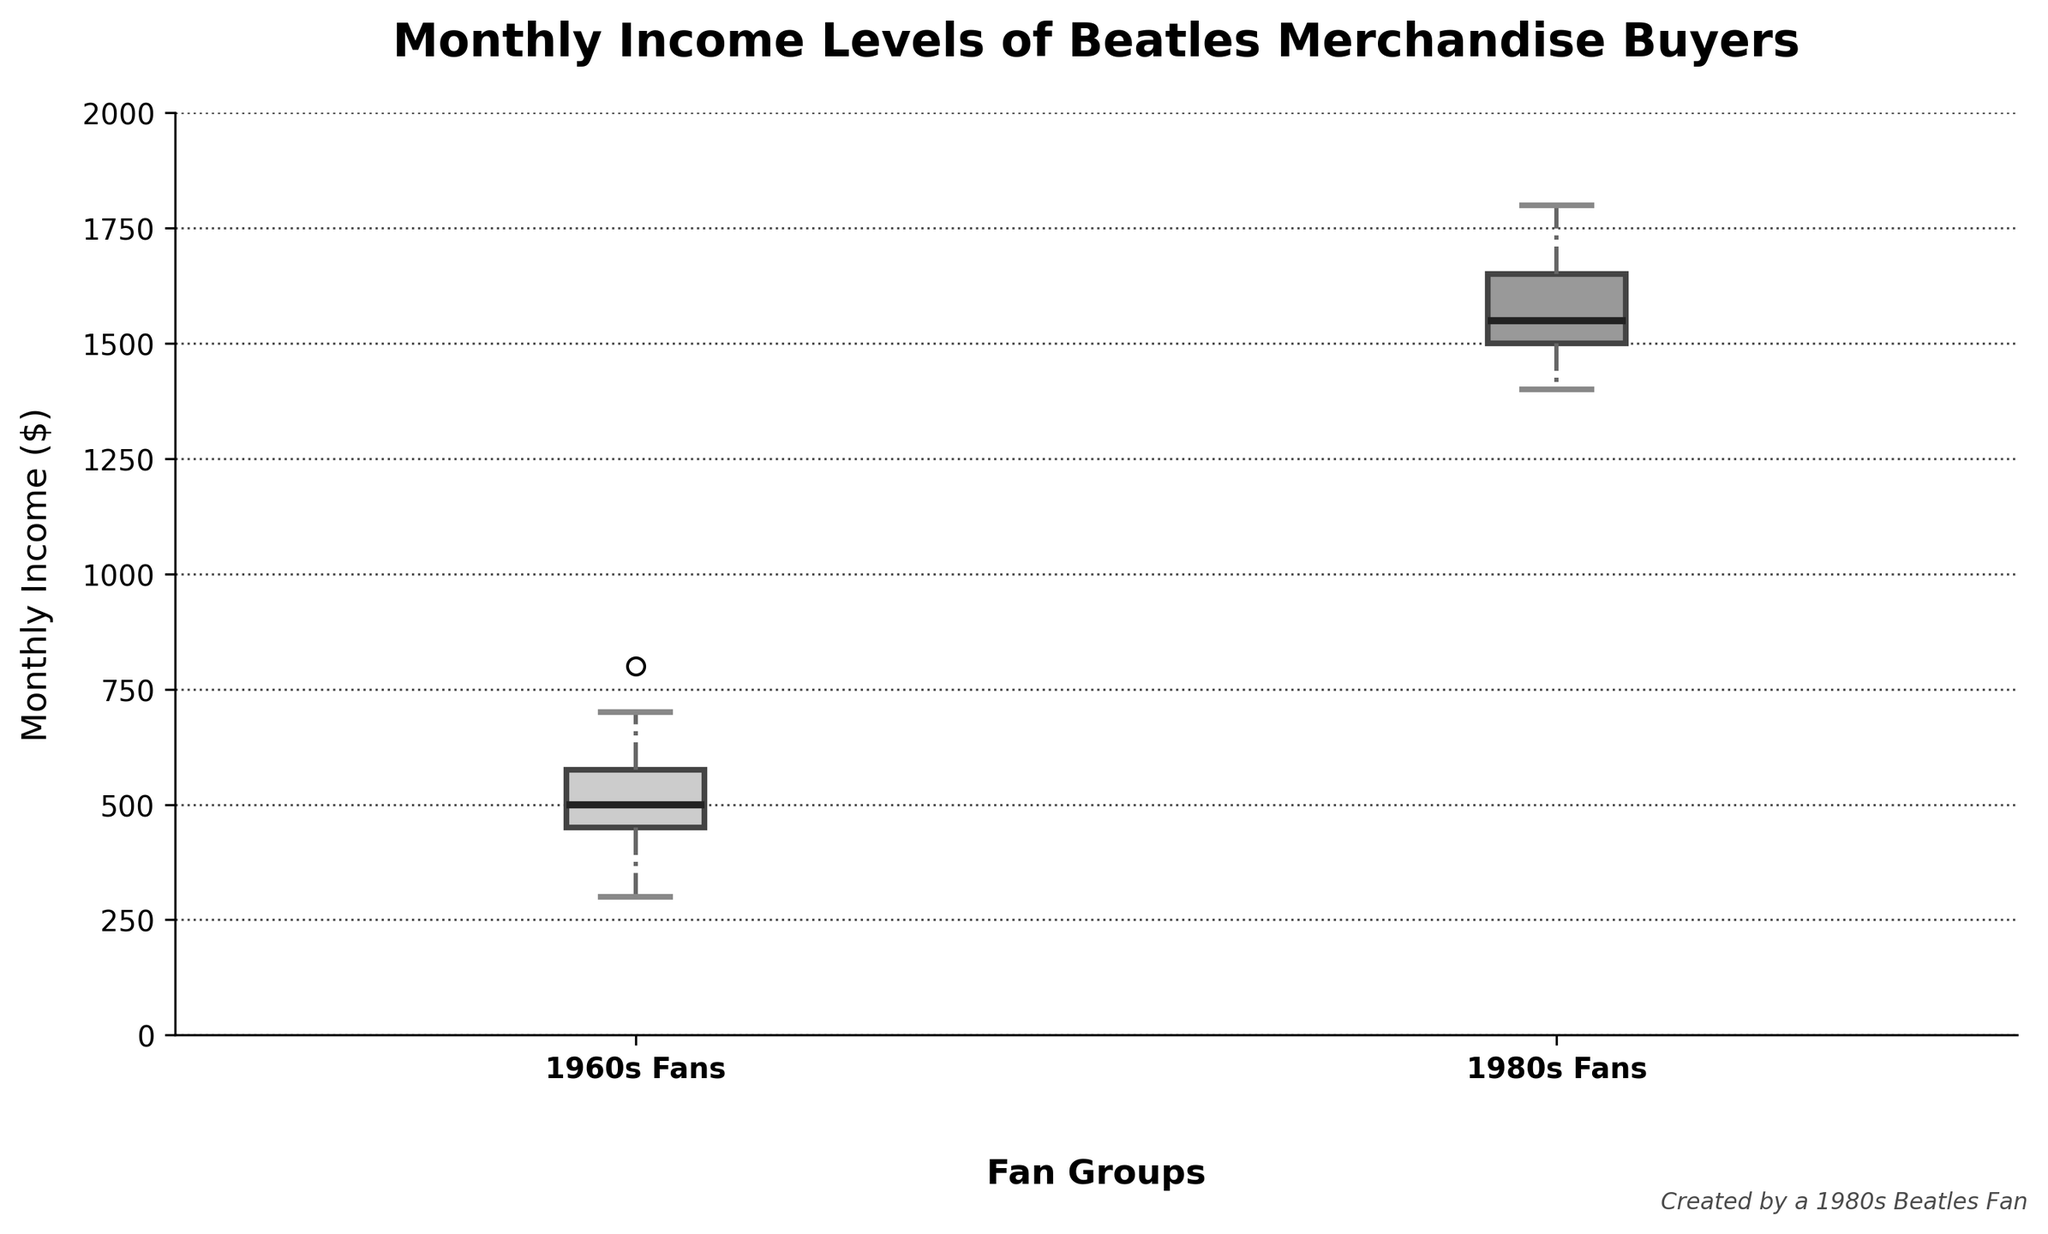What is the title of the plot? The title of the plot is visible at the top and reads "Monthly Income Levels of Beatles Merchandise Buyers."
Answer: Monthly Income Levels of Beatles Merchandise Buyers Which fan group has the higher median monthly income? By observing the median line inside each box, the group '1980s Fans' has a higher median monthly income compared to '1960s Fans'.
Answer: 1980s Fans What are the colors of the boxes representing the 1960s Fans and 1980s Fans groups? The box representing '1960s Fans' is light gray, and the box representing '1980s Fans' is dark gray.
Answer: Light gray and dark gray What is the median monthly income for 1960s Fans? The median income for the '1960s Fans' group can be observed by the horizontal line inside their box, which is around $500.
Answer: $500 What is the range of monthly incomes for 1980s Fans? The range can be determined by evaluating the maximum and minimum values of the whiskers for the '1980s Fans' box, which extend from approximately $1400 to $1800.
Answer: $1400-$1800 Which group shows a larger variation in monthly incomes? Variation can be assessed by the length of the boxes and the whiskers. '1980s Fans' exhibit larger whiskers, indicating more variation compared to '1960s Fans'.
Answer: 1980s Fans How does the interquartile range (IQR) of the 1980s Fans compare to that of the 1960s Fans? The IQR is the middle 50% of the data, represented by the length of the box. The '1980s Fans' group has a larger box indicating a larger IQR than the '1960s Fans'.
Answer: Larger for 1980s Fans Which group's maximum income is higher? The maximum income is shown by the upper whisker. The '1980s Fans' group has the higher maximum income, reaching about $1800, whereas the '1960s Fans' reach about $800.
Answer: 1980s Fans What is the lowest monthly income recorded for 1980s Fans? The lowest income can be seen at the bottom of the whisker for '1980s Fans', which is around $1400.
Answer: $1400 